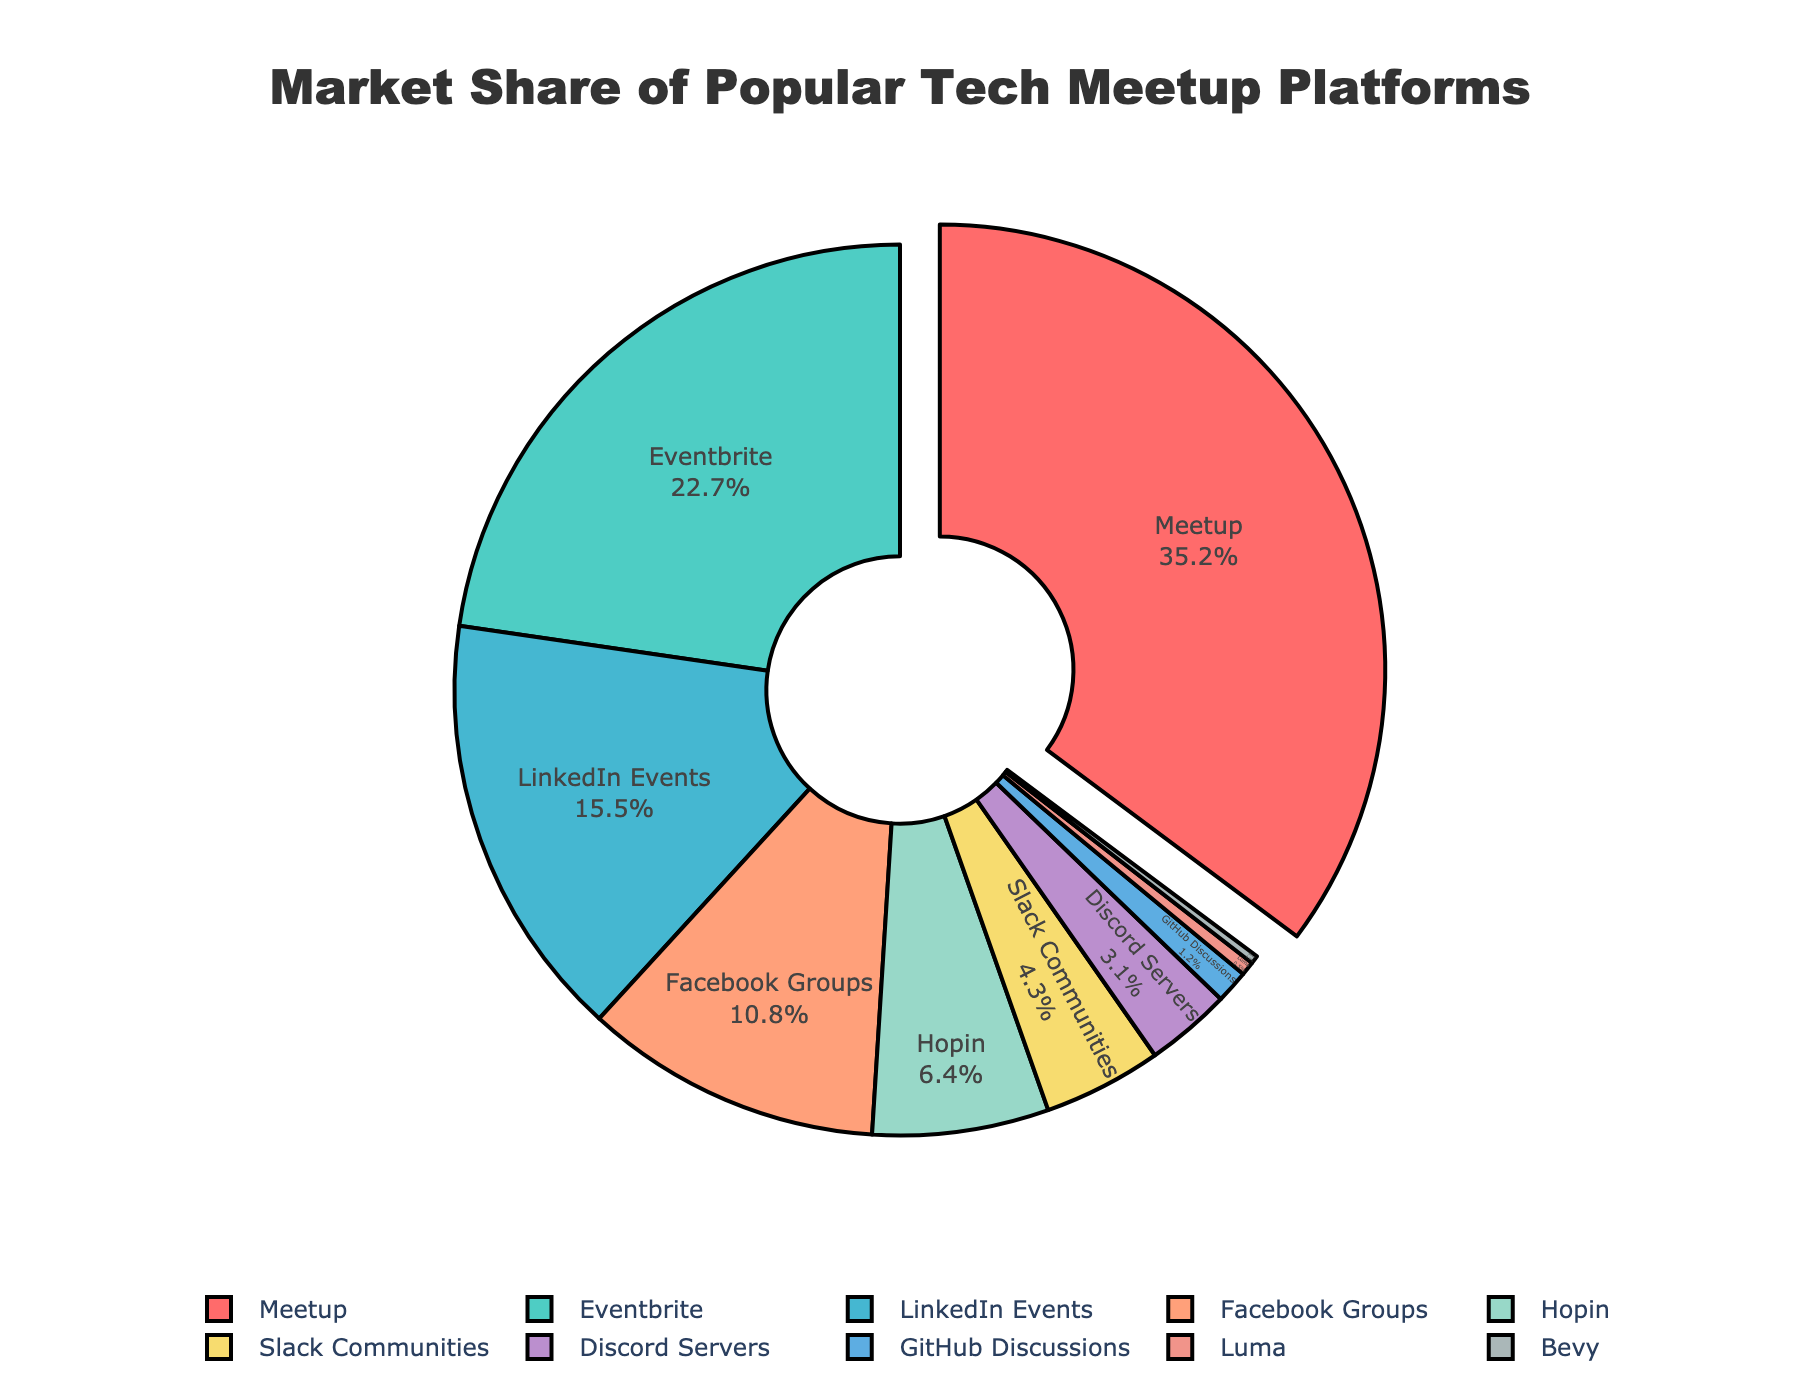Which platform has the largest market share? The platform names and their market shares are labeled on the pie chart. The largest portion of the pie chart belongs to Meetup, with 35.2%.
Answer: Meetup What is the combined market share of Facebook Groups and Slack Communities? First identify the market shares of Facebook Groups and Slack Communities from the pie chart, which are 10.8% and 4.3%, respectively. Then add these two values together: 10.8 + 4.3 = 15.1%.
Answer: 15.1% How does the market share of LinkedIn Events compare to that of Hopin? Compare the respective market shares of LinkedIn Events and Hopin from the pie chart. LinkedIn Events has a market share of 15.5%, while Hopin has 6.4%.
Answer: LinkedIn Events has a higher market share than Hopin Which platforms have a market share less than 5%? Look at the pie chart for the platforms with market shares less than 5%, which are Slack Communities (4.3%), Discord Servers (3.1%), GitHub Discussions (1.2%), Luma (0.5%), and Bevy (0.3%).
Answer: Slack Communities, Discord Servers, GitHub Discussions, Luma, Bevy What is the total market share for Eventbrite, Slack Communities, and GitHub Discussions? Find the individual market shares: Eventbrite (22.7%), Slack Communities (4.3%), GitHub Discussions (1.2%). Add them together: 22.7 + 4.3 + 1.2 = 28.2%.
Answer: 28.2% Which slice of the pie chart is pulled out? Observe the visual clue of the pie chart where the slice that is visually pulled out represents the platform with the largest market share, which is Meetup.
Answer: Meetup Is the market share of Meetup more than the combined market share of Facebook Groups, Slack Communities, and Discord Servers? Compare Meetup's market share (35.2%) with the sum of Facebook Groups (10.8%), Slack Communities (4.3%), and Discord Servers (3.1%). Adding the three gives 10.8 + 4.3 + 3.1 = 18.2%; 35.2% is greater than 18.2%.
Answer: Yes What is the approximate percentage difference between the market shares of Meetup and Eventbrite? Find the market shares of Meetup (35.2%) and Eventbrite (22.7%) and calculate the absolute difference: 35.2 - 22.7 = 12.5%.
Answer: 12.5% Which platforms have a market share equal to or greater than 10%? Refer to the pie chart data. The platforms with market shares equal to or greater than 10% are Meetup (35.2%), Eventbrite (22.7%), LinkedIn Events (15.5%), and Facebook Groups (10.8%).
Answer: Meetup, Eventbrite, LinkedIn Events, Facebook Groups 